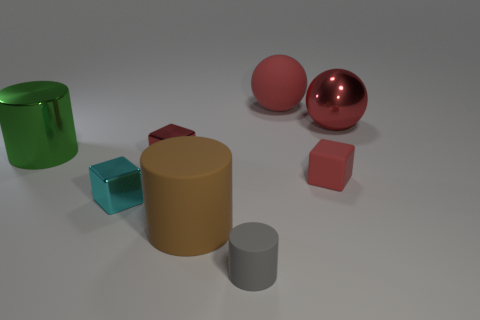Do the large metal thing that is left of the cyan thing and the matte thing that is to the left of the small cylinder have the same shape? Indeed, the large metal thing on the left of the cyan-colored box and the matte, earth-toned cylinder to the left of the small grey cylinder both possess a cylindrical shape. Their color and finish are different, however—the former has a reflective metallic surface, while the latter has a matte finish. 